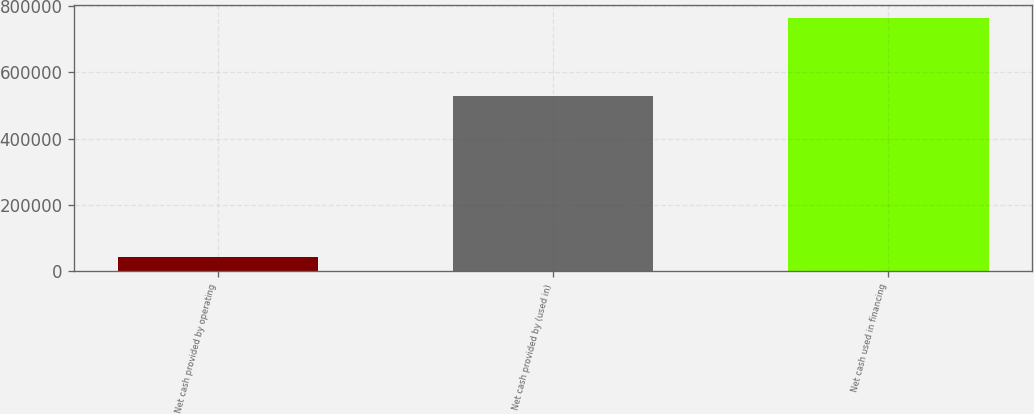<chart> <loc_0><loc_0><loc_500><loc_500><bar_chart><fcel>Net cash provided by operating<fcel>Net cash provided by (used in)<fcel>Net cash used in financing<nl><fcel>42743<fcel>527619<fcel>764868<nl></chart> 